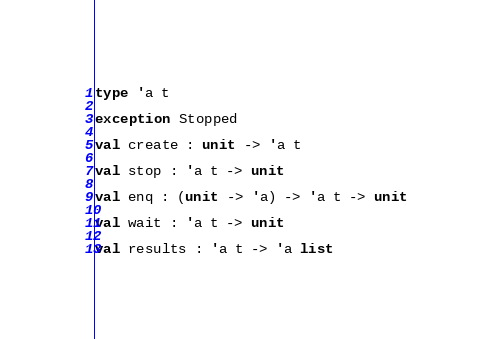Convert code to text. <code><loc_0><loc_0><loc_500><loc_500><_OCaml_>type 'a t
  
exception Stopped
  
val create : unit -> 'a t
  
val stop : 'a t -> unit
  
val enq : (unit -> 'a) -> 'a t -> unit
  
val wait : 'a t -> unit
  
val results : 'a t -> 'a list
</code> 